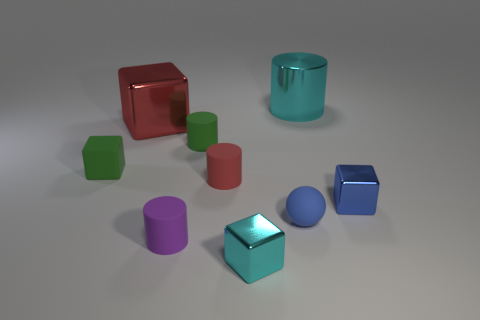Subtract all big cylinders. How many cylinders are left? 3 Add 1 big cyan metal cylinders. How many objects exist? 10 Subtract 1 balls. How many balls are left? 0 Subtract all green cubes. How many cubes are left? 3 Subtract all blocks. How many objects are left? 5 Subtract all purple cylinders. How many yellow balls are left? 0 Subtract all large red shiny cubes. Subtract all cubes. How many objects are left? 4 Add 2 rubber spheres. How many rubber spheres are left? 3 Add 1 small green matte cubes. How many small green matte cubes exist? 2 Subtract 0 yellow cubes. How many objects are left? 9 